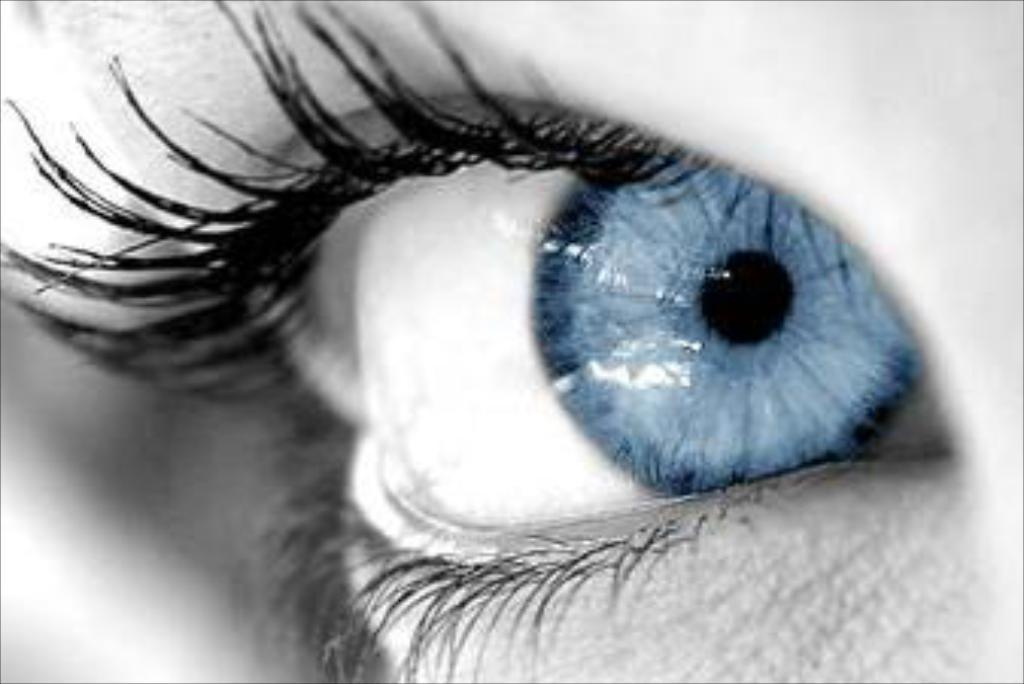What is the main subject of the image? There is an eye in the center of the image. What type of account does the ant have in the image? There is no ant or account present in the image; it only features an eye. What material is the lead used for in the image? There is no lead or any indication of its use in the image; it only features an eye. 